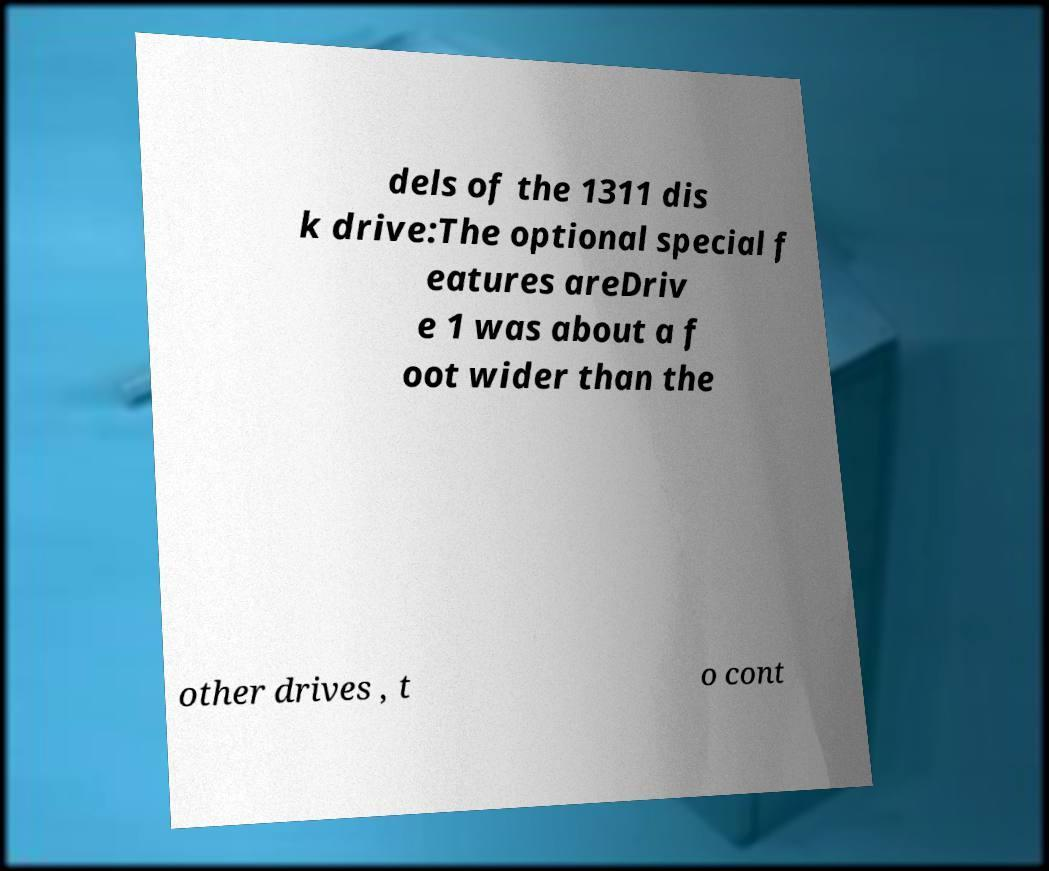Could you assist in decoding the text presented in this image and type it out clearly? dels of the 1311 dis k drive:The optional special f eatures areDriv e 1 was about a f oot wider than the other drives , t o cont 